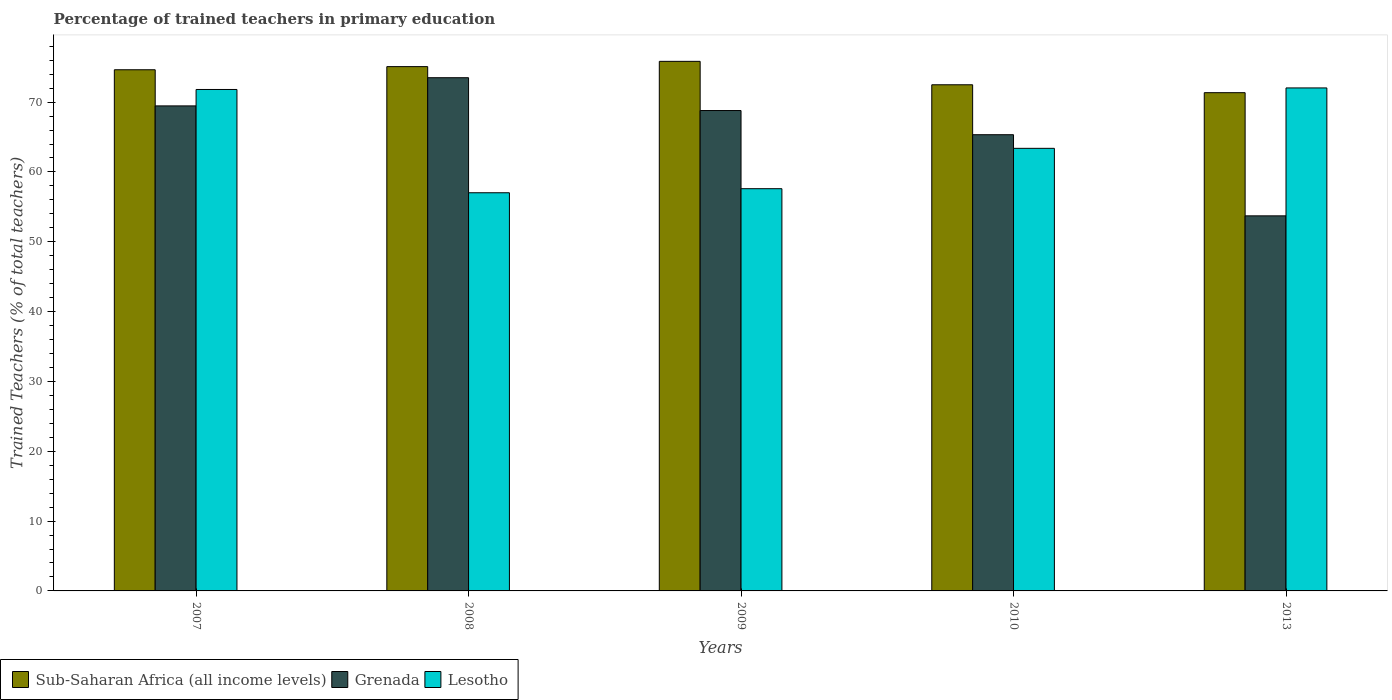How many different coloured bars are there?
Your response must be concise. 3. Are the number of bars per tick equal to the number of legend labels?
Provide a succinct answer. Yes. Are the number of bars on each tick of the X-axis equal?
Provide a succinct answer. Yes. In how many cases, is the number of bars for a given year not equal to the number of legend labels?
Keep it short and to the point. 0. What is the percentage of trained teachers in Grenada in 2013?
Give a very brief answer. 53.71. Across all years, what is the maximum percentage of trained teachers in Lesotho?
Your answer should be very brief. 72.03. Across all years, what is the minimum percentage of trained teachers in Sub-Saharan Africa (all income levels)?
Make the answer very short. 71.35. In which year was the percentage of trained teachers in Sub-Saharan Africa (all income levels) maximum?
Give a very brief answer. 2009. What is the total percentage of trained teachers in Lesotho in the graph?
Offer a very short reply. 321.85. What is the difference between the percentage of trained teachers in Sub-Saharan Africa (all income levels) in 2008 and that in 2009?
Give a very brief answer. -0.75. What is the difference between the percentage of trained teachers in Lesotho in 2008 and the percentage of trained teachers in Sub-Saharan Africa (all income levels) in 2009?
Provide a short and direct response. -18.82. What is the average percentage of trained teachers in Grenada per year?
Provide a succinct answer. 66.16. In the year 2013, what is the difference between the percentage of trained teachers in Grenada and percentage of trained teachers in Lesotho?
Give a very brief answer. -18.32. What is the ratio of the percentage of trained teachers in Sub-Saharan Africa (all income levels) in 2008 to that in 2013?
Ensure brevity in your answer.  1.05. Is the percentage of trained teachers in Sub-Saharan Africa (all income levels) in 2007 less than that in 2013?
Your response must be concise. No. Is the difference between the percentage of trained teachers in Grenada in 2007 and 2010 greater than the difference between the percentage of trained teachers in Lesotho in 2007 and 2010?
Provide a succinct answer. No. What is the difference between the highest and the second highest percentage of trained teachers in Sub-Saharan Africa (all income levels)?
Provide a short and direct response. 0.75. What is the difference between the highest and the lowest percentage of trained teachers in Sub-Saharan Africa (all income levels)?
Keep it short and to the point. 4.49. Is the sum of the percentage of trained teachers in Grenada in 2007 and 2008 greater than the maximum percentage of trained teachers in Sub-Saharan Africa (all income levels) across all years?
Your answer should be very brief. Yes. What does the 2nd bar from the left in 2010 represents?
Your answer should be compact. Grenada. What does the 1st bar from the right in 2009 represents?
Ensure brevity in your answer.  Lesotho. How many bars are there?
Provide a short and direct response. 15. Are all the bars in the graph horizontal?
Provide a short and direct response. No. What is the difference between two consecutive major ticks on the Y-axis?
Keep it short and to the point. 10. Are the values on the major ticks of Y-axis written in scientific E-notation?
Ensure brevity in your answer.  No. Where does the legend appear in the graph?
Make the answer very short. Bottom left. What is the title of the graph?
Your answer should be very brief. Percentage of trained teachers in primary education. Does "Luxembourg" appear as one of the legend labels in the graph?
Make the answer very short. No. What is the label or title of the X-axis?
Offer a very short reply. Years. What is the label or title of the Y-axis?
Your answer should be very brief. Trained Teachers (% of total teachers). What is the Trained Teachers (% of total teachers) of Sub-Saharan Africa (all income levels) in 2007?
Provide a succinct answer. 74.64. What is the Trained Teachers (% of total teachers) of Grenada in 2007?
Make the answer very short. 69.46. What is the Trained Teachers (% of total teachers) in Lesotho in 2007?
Make the answer very short. 71.81. What is the Trained Teachers (% of total teachers) of Sub-Saharan Africa (all income levels) in 2008?
Provide a succinct answer. 75.08. What is the Trained Teachers (% of total teachers) of Grenada in 2008?
Provide a short and direct response. 73.5. What is the Trained Teachers (% of total teachers) of Lesotho in 2008?
Your response must be concise. 57.02. What is the Trained Teachers (% of total teachers) of Sub-Saharan Africa (all income levels) in 2009?
Ensure brevity in your answer.  75.84. What is the Trained Teachers (% of total teachers) of Grenada in 2009?
Make the answer very short. 68.8. What is the Trained Teachers (% of total teachers) of Lesotho in 2009?
Your answer should be compact. 57.6. What is the Trained Teachers (% of total teachers) in Sub-Saharan Africa (all income levels) in 2010?
Your response must be concise. 72.49. What is the Trained Teachers (% of total teachers) in Grenada in 2010?
Your response must be concise. 65.33. What is the Trained Teachers (% of total teachers) in Lesotho in 2010?
Provide a short and direct response. 63.38. What is the Trained Teachers (% of total teachers) in Sub-Saharan Africa (all income levels) in 2013?
Offer a terse response. 71.35. What is the Trained Teachers (% of total teachers) in Grenada in 2013?
Offer a terse response. 53.71. What is the Trained Teachers (% of total teachers) of Lesotho in 2013?
Make the answer very short. 72.03. Across all years, what is the maximum Trained Teachers (% of total teachers) in Sub-Saharan Africa (all income levels)?
Make the answer very short. 75.84. Across all years, what is the maximum Trained Teachers (% of total teachers) of Grenada?
Keep it short and to the point. 73.5. Across all years, what is the maximum Trained Teachers (% of total teachers) of Lesotho?
Offer a very short reply. 72.03. Across all years, what is the minimum Trained Teachers (% of total teachers) in Sub-Saharan Africa (all income levels)?
Your answer should be very brief. 71.35. Across all years, what is the minimum Trained Teachers (% of total teachers) in Grenada?
Your answer should be compact. 53.71. Across all years, what is the minimum Trained Teachers (% of total teachers) of Lesotho?
Your answer should be very brief. 57.02. What is the total Trained Teachers (% of total teachers) of Sub-Saharan Africa (all income levels) in the graph?
Your response must be concise. 369.4. What is the total Trained Teachers (% of total teachers) of Grenada in the graph?
Offer a very short reply. 330.8. What is the total Trained Teachers (% of total teachers) of Lesotho in the graph?
Ensure brevity in your answer.  321.85. What is the difference between the Trained Teachers (% of total teachers) of Sub-Saharan Africa (all income levels) in 2007 and that in 2008?
Your response must be concise. -0.45. What is the difference between the Trained Teachers (% of total teachers) of Grenada in 2007 and that in 2008?
Your answer should be compact. -4.04. What is the difference between the Trained Teachers (% of total teachers) of Lesotho in 2007 and that in 2008?
Offer a terse response. 14.79. What is the difference between the Trained Teachers (% of total teachers) in Sub-Saharan Africa (all income levels) in 2007 and that in 2009?
Provide a short and direct response. -1.2. What is the difference between the Trained Teachers (% of total teachers) of Grenada in 2007 and that in 2009?
Your answer should be compact. 0.67. What is the difference between the Trained Teachers (% of total teachers) of Lesotho in 2007 and that in 2009?
Offer a very short reply. 14.21. What is the difference between the Trained Teachers (% of total teachers) in Sub-Saharan Africa (all income levels) in 2007 and that in 2010?
Offer a terse response. 2.15. What is the difference between the Trained Teachers (% of total teachers) of Grenada in 2007 and that in 2010?
Offer a terse response. 4.13. What is the difference between the Trained Teachers (% of total teachers) of Lesotho in 2007 and that in 2010?
Offer a terse response. 8.43. What is the difference between the Trained Teachers (% of total teachers) of Sub-Saharan Africa (all income levels) in 2007 and that in 2013?
Offer a very short reply. 3.28. What is the difference between the Trained Teachers (% of total teachers) in Grenada in 2007 and that in 2013?
Your answer should be very brief. 15.75. What is the difference between the Trained Teachers (% of total teachers) of Lesotho in 2007 and that in 2013?
Make the answer very short. -0.22. What is the difference between the Trained Teachers (% of total teachers) in Sub-Saharan Africa (all income levels) in 2008 and that in 2009?
Provide a succinct answer. -0.75. What is the difference between the Trained Teachers (% of total teachers) in Grenada in 2008 and that in 2009?
Offer a terse response. 4.7. What is the difference between the Trained Teachers (% of total teachers) in Lesotho in 2008 and that in 2009?
Give a very brief answer. -0.58. What is the difference between the Trained Teachers (% of total teachers) in Sub-Saharan Africa (all income levels) in 2008 and that in 2010?
Give a very brief answer. 2.6. What is the difference between the Trained Teachers (% of total teachers) in Grenada in 2008 and that in 2010?
Make the answer very short. 8.16. What is the difference between the Trained Teachers (% of total teachers) in Lesotho in 2008 and that in 2010?
Your answer should be compact. -6.36. What is the difference between the Trained Teachers (% of total teachers) of Sub-Saharan Africa (all income levels) in 2008 and that in 2013?
Provide a short and direct response. 3.73. What is the difference between the Trained Teachers (% of total teachers) in Grenada in 2008 and that in 2013?
Give a very brief answer. 19.78. What is the difference between the Trained Teachers (% of total teachers) of Lesotho in 2008 and that in 2013?
Give a very brief answer. -15.01. What is the difference between the Trained Teachers (% of total teachers) in Sub-Saharan Africa (all income levels) in 2009 and that in 2010?
Give a very brief answer. 3.35. What is the difference between the Trained Teachers (% of total teachers) of Grenada in 2009 and that in 2010?
Provide a short and direct response. 3.46. What is the difference between the Trained Teachers (% of total teachers) in Lesotho in 2009 and that in 2010?
Offer a very short reply. -5.78. What is the difference between the Trained Teachers (% of total teachers) in Sub-Saharan Africa (all income levels) in 2009 and that in 2013?
Keep it short and to the point. 4.49. What is the difference between the Trained Teachers (% of total teachers) in Grenada in 2009 and that in 2013?
Offer a very short reply. 15.08. What is the difference between the Trained Teachers (% of total teachers) of Lesotho in 2009 and that in 2013?
Give a very brief answer. -14.43. What is the difference between the Trained Teachers (% of total teachers) of Sub-Saharan Africa (all income levels) in 2010 and that in 2013?
Your response must be concise. 1.13. What is the difference between the Trained Teachers (% of total teachers) of Grenada in 2010 and that in 2013?
Keep it short and to the point. 11.62. What is the difference between the Trained Teachers (% of total teachers) in Lesotho in 2010 and that in 2013?
Give a very brief answer. -8.65. What is the difference between the Trained Teachers (% of total teachers) of Sub-Saharan Africa (all income levels) in 2007 and the Trained Teachers (% of total teachers) of Grenada in 2008?
Provide a short and direct response. 1.14. What is the difference between the Trained Teachers (% of total teachers) in Sub-Saharan Africa (all income levels) in 2007 and the Trained Teachers (% of total teachers) in Lesotho in 2008?
Offer a very short reply. 17.61. What is the difference between the Trained Teachers (% of total teachers) in Grenada in 2007 and the Trained Teachers (% of total teachers) in Lesotho in 2008?
Offer a terse response. 12.44. What is the difference between the Trained Teachers (% of total teachers) in Sub-Saharan Africa (all income levels) in 2007 and the Trained Teachers (% of total teachers) in Grenada in 2009?
Offer a terse response. 5.84. What is the difference between the Trained Teachers (% of total teachers) in Sub-Saharan Africa (all income levels) in 2007 and the Trained Teachers (% of total teachers) in Lesotho in 2009?
Give a very brief answer. 17.03. What is the difference between the Trained Teachers (% of total teachers) in Grenada in 2007 and the Trained Teachers (% of total teachers) in Lesotho in 2009?
Your answer should be very brief. 11.86. What is the difference between the Trained Teachers (% of total teachers) in Sub-Saharan Africa (all income levels) in 2007 and the Trained Teachers (% of total teachers) in Grenada in 2010?
Your response must be concise. 9.3. What is the difference between the Trained Teachers (% of total teachers) of Sub-Saharan Africa (all income levels) in 2007 and the Trained Teachers (% of total teachers) of Lesotho in 2010?
Provide a succinct answer. 11.25. What is the difference between the Trained Teachers (% of total teachers) of Grenada in 2007 and the Trained Teachers (% of total teachers) of Lesotho in 2010?
Offer a terse response. 6.08. What is the difference between the Trained Teachers (% of total teachers) in Sub-Saharan Africa (all income levels) in 2007 and the Trained Teachers (% of total teachers) in Grenada in 2013?
Ensure brevity in your answer.  20.92. What is the difference between the Trained Teachers (% of total teachers) in Sub-Saharan Africa (all income levels) in 2007 and the Trained Teachers (% of total teachers) in Lesotho in 2013?
Your answer should be compact. 2.6. What is the difference between the Trained Teachers (% of total teachers) in Grenada in 2007 and the Trained Teachers (% of total teachers) in Lesotho in 2013?
Your answer should be very brief. -2.57. What is the difference between the Trained Teachers (% of total teachers) in Sub-Saharan Africa (all income levels) in 2008 and the Trained Teachers (% of total teachers) in Grenada in 2009?
Provide a short and direct response. 6.29. What is the difference between the Trained Teachers (% of total teachers) in Sub-Saharan Africa (all income levels) in 2008 and the Trained Teachers (% of total teachers) in Lesotho in 2009?
Offer a very short reply. 17.48. What is the difference between the Trained Teachers (% of total teachers) in Grenada in 2008 and the Trained Teachers (% of total teachers) in Lesotho in 2009?
Your answer should be very brief. 15.89. What is the difference between the Trained Teachers (% of total teachers) in Sub-Saharan Africa (all income levels) in 2008 and the Trained Teachers (% of total teachers) in Grenada in 2010?
Provide a short and direct response. 9.75. What is the difference between the Trained Teachers (% of total teachers) of Sub-Saharan Africa (all income levels) in 2008 and the Trained Teachers (% of total teachers) of Lesotho in 2010?
Offer a very short reply. 11.7. What is the difference between the Trained Teachers (% of total teachers) of Grenada in 2008 and the Trained Teachers (% of total teachers) of Lesotho in 2010?
Offer a very short reply. 10.11. What is the difference between the Trained Teachers (% of total teachers) of Sub-Saharan Africa (all income levels) in 2008 and the Trained Teachers (% of total teachers) of Grenada in 2013?
Your answer should be very brief. 21.37. What is the difference between the Trained Teachers (% of total teachers) in Sub-Saharan Africa (all income levels) in 2008 and the Trained Teachers (% of total teachers) in Lesotho in 2013?
Give a very brief answer. 3.05. What is the difference between the Trained Teachers (% of total teachers) of Grenada in 2008 and the Trained Teachers (% of total teachers) of Lesotho in 2013?
Offer a very short reply. 1.46. What is the difference between the Trained Teachers (% of total teachers) of Sub-Saharan Africa (all income levels) in 2009 and the Trained Teachers (% of total teachers) of Grenada in 2010?
Your answer should be compact. 10.5. What is the difference between the Trained Teachers (% of total teachers) in Sub-Saharan Africa (all income levels) in 2009 and the Trained Teachers (% of total teachers) in Lesotho in 2010?
Your answer should be compact. 12.46. What is the difference between the Trained Teachers (% of total teachers) of Grenada in 2009 and the Trained Teachers (% of total teachers) of Lesotho in 2010?
Your response must be concise. 5.41. What is the difference between the Trained Teachers (% of total teachers) of Sub-Saharan Africa (all income levels) in 2009 and the Trained Teachers (% of total teachers) of Grenada in 2013?
Your answer should be very brief. 22.13. What is the difference between the Trained Teachers (% of total teachers) in Sub-Saharan Africa (all income levels) in 2009 and the Trained Teachers (% of total teachers) in Lesotho in 2013?
Provide a succinct answer. 3.81. What is the difference between the Trained Teachers (% of total teachers) of Grenada in 2009 and the Trained Teachers (% of total teachers) of Lesotho in 2013?
Make the answer very short. -3.24. What is the difference between the Trained Teachers (% of total teachers) of Sub-Saharan Africa (all income levels) in 2010 and the Trained Teachers (% of total teachers) of Grenada in 2013?
Make the answer very short. 18.77. What is the difference between the Trained Teachers (% of total teachers) in Sub-Saharan Africa (all income levels) in 2010 and the Trained Teachers (% of total teachers) in Lesotho in 2013?
Make the answer very short. 0.45. What is the difference between the Trained Teachers (% of total teachers) in Grenada in 2010 and the Trained Teachers (% of total teachers) in Lesotho in 2013?
Your answer should be very brief. -6.7. What is the average Trained Teachers (% of total teachers) in Sub-Saharan Africa (all income levels) per year?
Make the answer very short. 73.88. What is the average Trained Teachers (% of total teachers) in Grenada per year?
Your answer should be very brief. 66.16. What is the average Trained Teachers (% of total teachers) of Lesotho per year?
Make the answer very short. 64.37. In the year 2007, what is the difference between the Trained Teachers (% of total teachers) in Sub-Saharan Africa (all income levels) and Trained Teachers (% of total teachers) in Grenada?
Your answer should be very brief. 5.18. In the year 2007, what is the difference between the Trained Teachers (% of total teachers) in Sub-Saharan Africa (all income levels) and Trained Teachers (% of total teachers) in Lesotho?
Keep it short and to the point. 2.82. In the year 2007, what is the difference between the Trained Teachers (% of total teachers) in Grenada and Trained Teachers (% of total teachers) in Lesotho?
Ensure brevity in your answer.  -2.35. In the year 2008, what is the difference between the Trained Teachers (% of total teachers) of Sub-Saharan Africa (all income levels) and Trained Teachers (% of total teachers) of Grenada?
Provide a succinct answer. 1.59. In the year 2008, what is the difference between the Trained Teachers (% of total teachers) in Sub-Saharan Africa (all income levels) and Trained Teachers (% of total teachers) in Lesotho?
Provide a succinct answer. 18.06. In the year 2008, what is the difference between the Trained Teachers (% of total teachers) in Grenada and Trained Teachers (% of total teachers) in Lesotho?
Your answer should be compact. 16.47. In the year 2009, what is the difference between the Trained Teachers (% of total teachers) in Sub-Saharan Africa (all income levels) and Trained Teachers (% of total teachers) in Grenada?
Make the answer very short. 7.04. In the year 2009, what is the difference between the Trained Teachers (% of total teachers) of Sub-Saharan Africa (all income levels) and Trained Teachers (% of total teachers) of Lesotho?
Your response must be concise. 18.24. In the year 2009, what is the difference between the Trained Teachers (% of total teachers) in Grenada and Trained Teachers (% of total teachers) in Lesotho?
Provide a succinct answer. 11.19. In the year 2010, what is the difference between the Trained Teachers (% of total teachers) in Sub-Saharan Africa (all income levels) and Trained Teachers (% of total teachers) in Grenada?
Your answer should be very brief. 7.15. In the year 2010, what is the difference between the Trained Teachers (% of total teachers) in Sub-Saharan Africa (all income levels) and Trained Teachers (% of total teachers) in Lesotho?
Ensure brevity in your answer.  9.1. In the year 2010, what is the difference between the Trained Teachers (% of total teachers) of Grenada and Trained Teachers (% of total teachers) of Lesotho?
Keep it short and to the point. 1.95. In the year 2013, what is the difference between the Trained Teachers (% of total teachers) in Sub-Saharan Africa (all income levels) and Trained Teachers (% of total teachers) in Grenada?
Offer a terse response. 17.64. In the year 2013, what is the difference between the Trained Teachers (% of total teachers) in Sub-Saharan Africa (all income levels) and Trained Teachers (% of total teachers) in Lesotho?
Provide a short and direct response. -0.68. In the year 2013, what is the difference between the Trained Teachers (% of total teachers) in Grenada and Trained Teachers (% of total teachers) in Lesotho?
Your answer should be very brief. -18.32. What is the ratio of the Trained Teachers (% of total teachers) of Sub-Saharan Africa (all income levels) in 2007 to that in 2008?
Provide a short and direct response. 0.99. What is the ratio of the Trained Teachers (% of total teachers) of Grenada in 2007 to that in 2008?
Your answer should be very brief. 0.95. What is the ratio of the Trained Teachers (% of total teachers) of Lesotho in 2007 to that in 2008?
Give a very brief answer. 1.26. What is the ratio of the Trained Teachers (% of total teachers) in Sub-Saharan Africa (all income levels) in 2007 to that in 2009?
Offer a very short reply. 0.98. What is the ratio of the Trained Teachers (% of total teachers) in Grenada in 2007 to that in 2009?
Give a very brief answer. 1.01. What is the ratio of the Trained Teachers (% of total teachers) in Lesotho in 2007 to that in 2009?
Make the answer very short. 1.25. What is the ratio of the Trained Teachers (% of total teachers) of Sub-Saharan Africa (all income levels) in 2007 to that in 2010?
Your response must be concise. 1.03. What is the ratio of the Trained Teachers (% of total teachers) of Grenada in 2007 to that in 2010?
Provide a short and direct response. 1.06. What is the ratio of the Trained Teachers (% of total teachers) of Lesotho in 2007 to that in 2010?
Provide a short and direct response. 1.13. What is the ratio of the Trained Teachers (% of total teachers) of Sub-Saharan Africa (all income levels) in 2007 to that in 2013?
Keep it short and to the point. 1.05. What is the ratio of the Trained Teachers (% of total teachers) in Grenada in 2007 to that in 2013?
Your answer should be compact. 1.29. What is the ratio of the Trained Teachers (% of total teachers) in Lesotho in 2007 to that in 2013?
Provide a short and direct response. 1. What is the ratio of the Trained Teachers (% of total teachers) of Grenada in 2008 to that in 2009?
Keep it short and to the point. 1.07. What is the ratio of the Trained Teachers (% of total teachers) in Lesotho in 2008 to that in 2009?
Ensure brevity in your answer.  0.99. What is the ratio of the Trained Teachers (% of total teachers) of Sub-Saharan Africa (all income levels) in 2008 to that in 2010?
Offer a terse response. 1.04. What is the ratio of the Trained Teachers (% of total teachers) in Grenada in 2008 to that in 2010?
Make the answer very short. 1.12. What is the ratio of the Trained Teachers (% of total teachers) in Lesotho in 2008 to that in 2010?
Ensure brevity in your answer.  0.9. What is the ratio of the Trained Teachers (% of total teachers) in Sub-Saharan Africa (all income levels) in 2008 to that in 2013?
Offer a terse response. 1.05. What is the ratio of the Trained Teachers (% of total teachers) of Grenada in 2008 to that in 2013?
Keep it short and to the point. 1.37. What is the ratio of the Trained Teachers (% of total teachers) in Lesotho in 2008 to that in 2013?
Keep it short and to the point. 0.79. What is the ratio of the Trained Teachers (% of total teachers) in Sub-Saharan Africa (all income levels) in 2009 to that in 2010?
Offer a terse response. 1.05. What is the ratio of the Trained Teachers (% of total teachers) of Grenada in 2009 to that in 2010?
Provide a short and direct response. 1.05. What is the ratio of the Trained Teachers (% of total teachers) of Lesotho in 2009 to that in 2010?
Your answer should be compact. 0.91. What is the ratio of the Trained Teachers (% of total teachers) of Sub-Saharan Africa (all income levels) in 2009 to that in 2013?
Provide a short and direct response. 1.06. What is the ratio of the Trained Teachers (% of total teachers) in Grenada in 2009 to that in 2013?
Your response must be concise. 1.28. What is the ratio of the Trained Teachers (% of total teachers) of Lesotho in 2009 to that in 2013?
Provide a succinct answer. 0.8. What is the ratio of the Trained Teachers (% of total teachers) in Sub-Saharan Africa (all income levels) in 2010 to that in 2013?
Offer a terse response. 1.02. What is the ratio of the Trained Teachers (% of total teachers) in Grenada in 2010 to that in 2013?
Offer a terse response. 1.22. What is the ratio of the Trained Teachers (% of total teachers) of Lesotho in 2010 to that in 2013?
Your answer should be very brief. 0.88. What is the difference between the highest and the second highest Trained Teachers (% of total teachers) of Sub-Saharan Africa (all income levels)?
Offer a very short reply. 0.75. What is the difference between the highest and the second highest Trained Teachers (% of total teachers) in Grenada?
Ensure brevity in your answer.  4.04. What is the difference between the highest and the second highest Trained Teachers (% of total teachers) of Lesotho?
Offer a very short reply. 0.22. What is the difference between the highest and the lowest Trained Teachers (% of total teachers) of Sub-Saharan Africa (all income levels)?
Provide a succinct answer. 4.49. What is the difference between the highest and the lowest Trained Teachers (% of total teachers) in Grenada?
Offer a very short reply. 19.78. What is the difference between the highest and the lowest Trained Teachers (% of total teachers) in Lesotho?
Your answer should be compact. 15.01. 